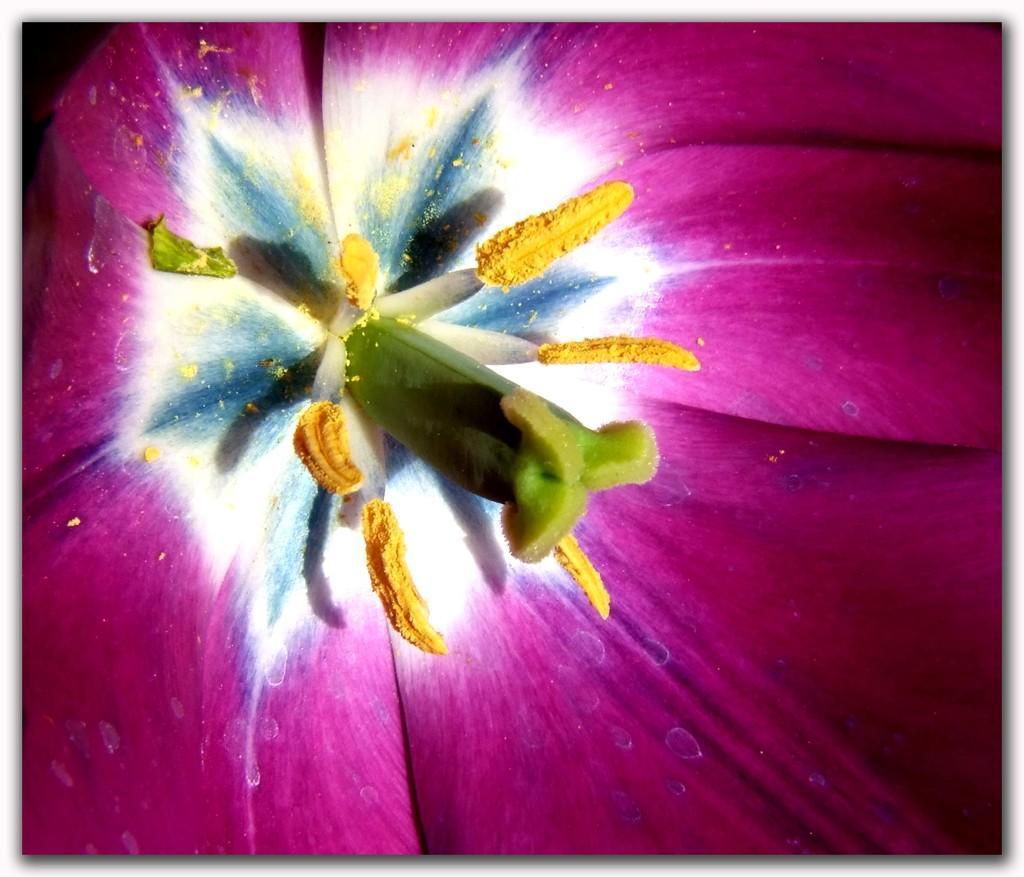What is the main subject of the image? There is a flower in the image. Can you describe any specific features of the flower? Pollen grains are present in the middle of the flower. What type of brush is being used to apply paint to the flower in the image? There is no brush or paint present in the image; it features a flower with pollen grains. How many wrenches are visible in the image? There are no wrenches present in the image; it features a flower with pollen grains. 